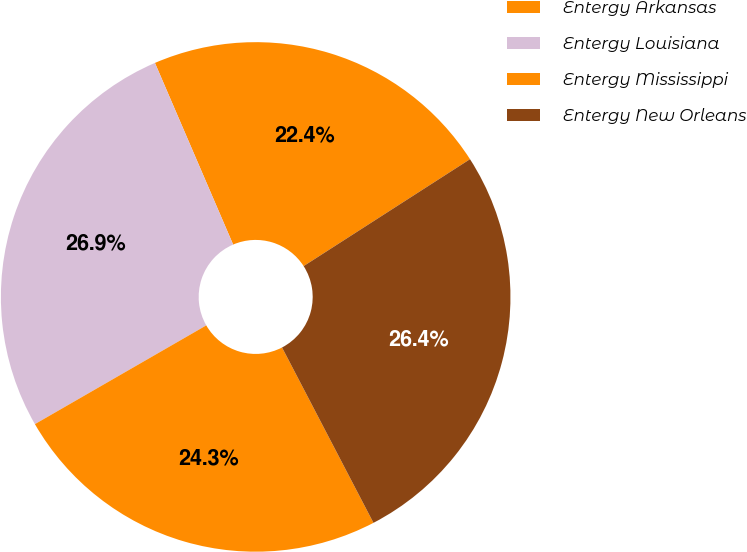Convert chart to OTSL. <chart><loc_0><loc_0><loc_500><loc_500><pie_chart><fcel>Entergy Arkansas<fcel>Entergy Louisiana<fcel>Entergy Mississippi<fcel>Entergy New Orleans<nl><fcel>22.38%<fcel>26.85%<fcel>24.33%<fcel>26.44%<nl></chart> 